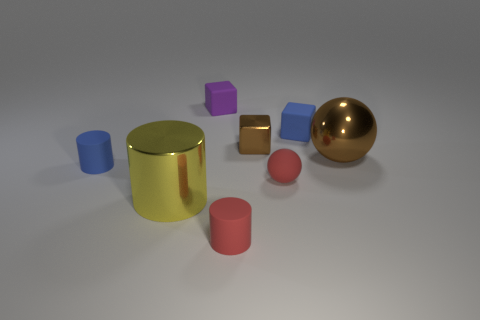Subtract 1 cylinders. How many cylinders are left? 2 Subtract all small cylinders. How many cylinders are left? 1 Add 1 red rubber balls. How many objects exist? 9 Subtract all balls. How many objects are left? 6 Subtract all cyan cylinders. Subtract all blue balls. How many cylinders are left? 3 Add 5 red rubber spheres. How many red rubber spheres are left? 6 Add 6 tiny purple things. How many tiny purple things exist? 7 Subtract 1 blue cylinders. How many objects are left? 7 Subtract all yellow shiny cylinders. Subtract all purple objects. How many objects are left? 6 